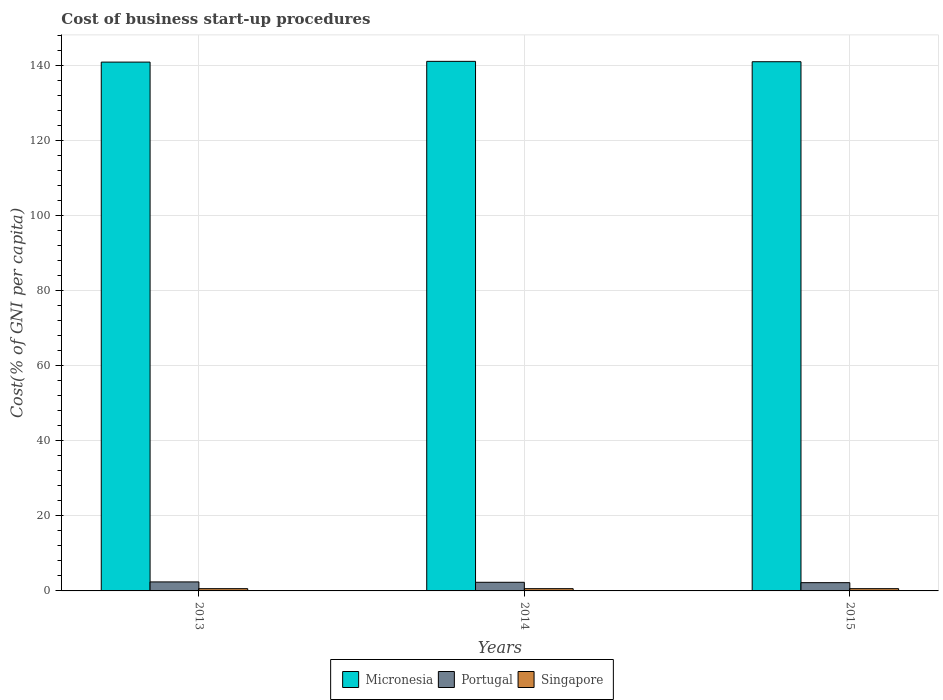How many groups of bars are there?
Your answer should be very brief. 3. Are the number of bars on each tick of the X-axis equal?
Your answer should be very brief. Yes. How many bars are there on the 1st tick from the left?
Give a very brief answer. 3. In how many cases, is the number of bars for a given year not equal to the number of legend labels?
Offer a terse response. 0. What is the cost of business start-up procedures in Micronesia in 2013?
Give a very brief answer. 141. In which year was the cost of business start-up procedures in Portugal maximum?
Give a very brief answer. 2013. In which year was the cost of business start-up procedures in Singapore minimum?
Provide a succinct answer. 2013. What is the total cost of business start-up procedures in Singapore in the graph?
Your response must be concise. 1.8. What is the difference between the cost of business start-up procedures in Portugal in 2013 and that in 2014?
Your answer should be very brief. 0.1. What is the difference between the cost of business start-up procedures in Singapore in 2015 and the cost of business start-up procedures in Portugal in 2013?
Offer a very short reply. -1.8. What is the average cost of business start-up procedures in Portugal per year?
Keep it short and to the point. 2.3. In the year 2013, what is the difference between the cost of business start-up procedures in Portugal and cost of business start-up procedures in Micronesia?
Give a very brief answer. -138.6. In how many years, is the cost of business start-up procedures in Micronesia greater than 76 %?
Make the answer very short. 3. What is the ratio of the cost of business start-up procedures in Singapore in 2014 to that in 2015?
Offer a very short reply. 1. What is the difference between the highest and the second highest cost of business start-up procedures in Singapore?
Your answer should be very brief. 0. What is the difference between the highest and the lowest cost of business start-up procedures in Singapore?
Offer a terse response. 0. In how many years, is the cost of business start-up procedures in Singapore greater than the average cost of business start-up procedures in Singapore taken over all years?
Provide a succinct answer. 0. What does the 3rd bar from the left in 2014 represents?
Keep it short and to the point. Singapore. What does the 1st bar from the right in 2013 represents?
Ensure brevity in your answer.  Singapore. How many legend labels are there?
Your answer should be compact. 3. What is the title of the graph?
Keep it short and to the point. Cost of business start-up procedures. Does "Turks and Caicos Islands" appear as one of the legend labels in the graph?
Your answer should be very brief. No. What is the label or title of the Y-axis?
Keep it short and to the point. Cost(% of GNI per capita). What is the Cost(% of GNI per capita) in Micronesia in 2013?
Provide a short and direct response. 141. What is the Cost(% of GNI per capita) of Portugal in 2013?
Ensure brevity in your answer.  2.4. What is the Cost(% of GNI per capita) of Micronesia in 2014?
Keep it short and to the point. 141.2. What is the Cost(% of GNI per capita) of Singapore in 2014?
Make the answer very short. 0.6. What is the Cost(% of GNI per capita) in Micronesia in 2015?
Offer a very short reply. 141.1. What is the Cost(% of GNI per capita) of Portugal in 2015?
Provide a succinct answer. 2.2. Across all years, what is the maximum Cost(% of GNI per capita) in Micronesia?
Ensure brevity in your answer.  141.2. Across all years, what is the maximum Cost(% of GNI per capita) of Singapore?
Make the answer very short. 0.6. Across all years, what is the minimum Cost(% of GNI per capita) in Micronesia?
Provide a succinct answer. 141. What is the total Cost(% of GNI per capita) of Micronesia in the graph?
Your answer should be compact. 423.3. What is the total Cost(% of GNI per capita) in Portugal in the graph?
Provide a succinct answer. 6.9. What is the difference between the Cost(% of GNI per capita) of Micronesia in 2013 and that in 2014?
Provide a succinct answer. -0.2. What is the difference between the Cost(% of GNI per capita) of Singapore in 2013 and that in 2014?
Give a very brief answer. 0. What is the difference between the Cost(% of GNI per capita) in Portugal in 2013 and that in 2015?
Offer a terse response. 0.2. What is the difference between the Cost(% of GNI per capita) of Portugal in 2014 and that in 2015?
Your answer should be compact. 0.1. What is the difference between the Cost(% of GNI per capita) of Singapore in 2014 and that in 2015?
Give a very brief answer. 0. What is the difference between the Cost(% of GNI per capita) of Micronesia in 2013 and the Cost(% of GNI per capita) of Portugal in 2014?
Your answer should be very brief. 138.7. What is the difference between the Cost(% of GNI per capita) in Micronesia in 2013 and the Cost(% of GNI per capita) in Singapore in 2014?
Your response must be concise. 140.4. What is the difference between the Cost(% of GNI per capita) in Micronesia in 2013 and the Cost(% of GNI per capita) in Portugal in 2015?
Provide a short and direct response. 138.8. What is the difference between the Cost(% of GNI per capita) of Micronesia in 2013 and the Cost(% of GNI per capita) of Singapore in 2015?
Your answer should be very brief. 140.4. What is the difference between the Cost(% of GNI per capita) in Portugal in 2013 and the Cost(% of GNI per capita) in Singapore in 2015?
Your answer should be compact. 1.8. What is the difference between the Cost(% of GNI per capita) in Micronesia in 2014 and the Cost(% of GNI per capita) in Portugal in 2015?
Ensure brevity in your answer.  139. What is the difference between the Cost(% of GNI per capita) of Micronesia in 2014 and the Cost(% of GNI per capita) of Singapore in 2015?
Give a very brief answer. 140.6. What is the average Cost(% of GNI per capita) of Micronesia per year?
Provide a succinct answer. 141.1. What is the average Cost(% of GNI per capita) in Singapore per year?
Your answer should be compact. 0.6. In the year 2013, what is the difference between the Cost(% of GNI per capita) in Micronesia and Cost(% of GNI per capita) in Portugal?
Provide a short and direct response. 138.6. In the year 2013, what is the difference between the Cost(% of GNI per capita) of Micronesia and Cost(% of GNI per capita) of Singapore?
Offer a very short reply. 140.4. In the year 2014, what is the difference between the Cost(% of GNI per capita) of Micronesia and Cost(% of GNI per capita) of Portugal?
Give a very brief answer. 138.9. In the year 2014, what is the difference between the Cost(% of GNI per capita) of Micronesia and Cost(% of GNI per capita) of Singapore?
Offer a terse response. 140.6. In the year 2015, what is the difference between the Cost(% of GNI per capita) of Micronesia and Cost(% of GNI per capita) of Portugal?
Make the answer very short. 138.9. In the year 2015, what is the difference between the Cost(% of GNI per capita) in Micronesia and Cost(% of GNI per capita) in Singapore?
Your answer should be compact. 140.5. What is the ratio of the Cost(% of GNI per capita) in Micronesia in 2013 to that in 2014?
Ensure brevity in your answer.  1. What is the ratio of the Cost(% of GNI per capita) of Portugal in 2013 to that in 2014?
Your answer should be very brief. 1.04. What is the ratio of the Cost(% of GNI per capita) of Singapore in 2013 to that in 2014?
Provide a succinct answer. 1. What is the ratio of the Cost(% of GNI per capita) of Micronesia in 2013 to that in 2015?
Keep it short and to the point. 1. What is the ratio of the Cost(% of GNI per capita) of Portugal in 2013 to that in 2015?
Provide a succinct answer. 1.09. What is the ratio of the Cost(% of GNI per capita) in Micronesia in 2014 to that in 2015?
Your answer should be very brief. 1. What is the ratio of the Cost(% of GNI per capita) in Portugal in 2014 to that in 2015?
Ensure brevity in your answer.  1.05. What is the ratio of the Cost(% of GNI per capita) of Singapore in 2014 to that in 2015?
Your answer should be very brief. 1. What is the difference between the highest and the second highest Cost(% of GNI per capita) in Micronesia?
Provide a short and direct response. 0.1. What is the difference between the highest and the second highest Cost(% of GNI per capita) in Singapore?
Your answer should be very brief. 0. What is the difference between the highest and the lowest Cost(% of GNI per capita) in Portugal?
Your answer should be compact. 0.2. 